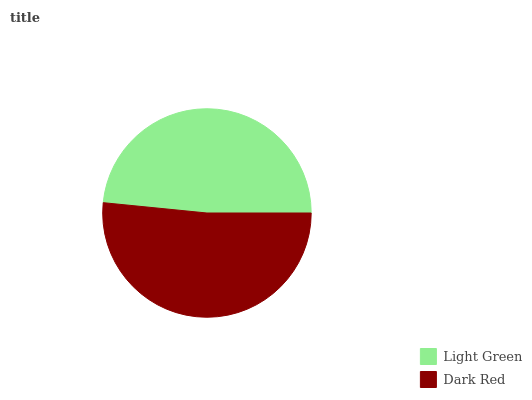Is Light Green the minimum?
Answer yes or no. Yes. Is Dark Red the maximum?
Answer yes or no. Yes. Is Dark Red the minimum?
Answer yes or no. No. Is Dark Red greater than Light Green?
Answer yes or no. Yes. Is Light Green less than Dark Red?
Answer yes or no. Yes. Is Light Green greater than Dark Red?
Answer yes or no. No. Is Dark Red less than Light Green?
Answer yes or no. No. Is Dark Red the high median?
Answer yes or no. Yes. Is Light Green the low median?
Answer yes or no. Yes. Is Light Green the high median?
Answer yes or no. No. Is Dark Red the low median?
Answer yes or no. No. 